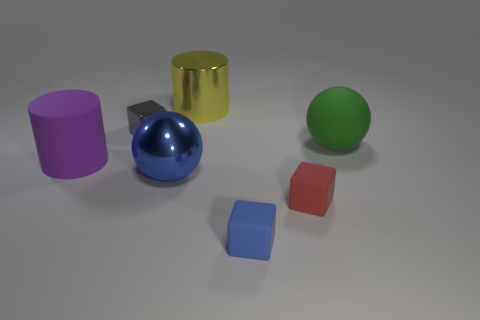What color is the small object to the right of the small block in front of the red object?
Make the answer very short. Red. What number of small things are either green metallic spheres or purple things?
Ensure brevity in your answer.  0. What is the material of the green object that is the same shape as the big blue object?
Offer a terse response. Rubber. Is there any other thing that has the same material as the blue cube?
Offer a terse response. Yes. The big shiny cylinder is what color?
Keep it short and to the point. Yellow. Is the large metal cylinder the same color as the rubber cylinder?
Provide a short and direct response. No. What number of purple cylinders are on the left side of the large rubber thing behind the big rubber cylinder?
Give a very brief answer. 1. There is a matte thing that is behind the small red matte block and to the left of the red cube; what is its size?
Provide a short and direct response. Large. What material is the cube behind the red rubber object?
Your answer should be compact. Metal. Is there another thing that has the same shape as the big blue object?
Keep it short and to the point. Yes. 